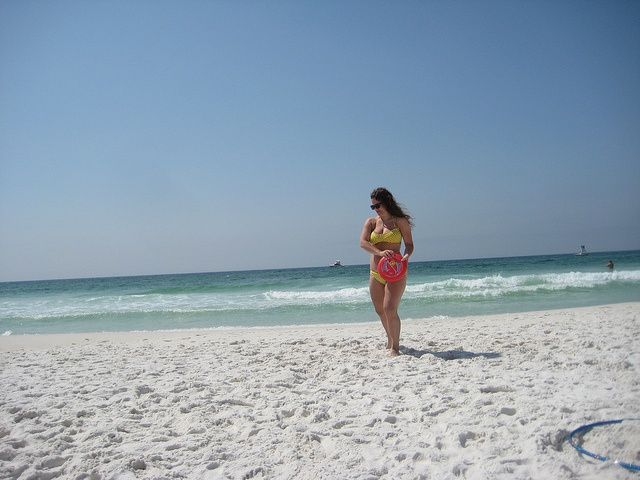Describe the objects in this image and their specific colors. I can see people in gray, brown, and maroon tones, frisbee in gray and brown tones, boat in gray and blue tones, boat in gray, darkgray, blue, and darkblue tones, and people in gray, black, and purple tones in this image. 